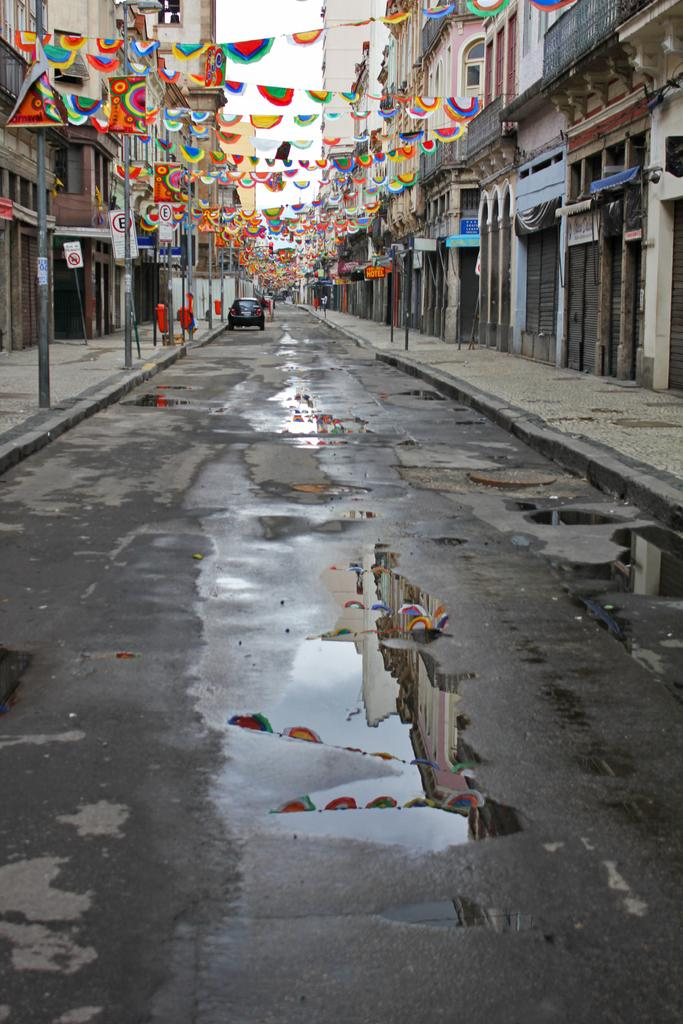What is the main feature in the center of the image? There is a road in the center of the image. What is on the road in the image? There is a car on the road. What objects can be seen alongside the road? There are poles in the image. What type of structures are visible in the image? There are buildings in the image. What is at the top of the image? There are flags at the top of the image. What can be seen in the background of the image? The sky is visible in the background of the image. What type of mailbox can be seen in the image? There is no mailbox present in the image. What is the value of the discussion taking place in the image? There is no discussion taking place in the image, so it's not possible to determine its value. 